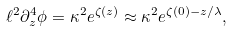Convert formula to latex. <formula><loc_0><loc_0><loc_500><loc_500>\ell ^ { 2 } \partial _ { z } ^ { 4 } \phi = \kappa ^ { 2 } e ^ { \zeta ( z ) } \approx \kappa ^ { 2 } e ^ { \zeta ( 0 ) - z / \lambda } ,</formula> 